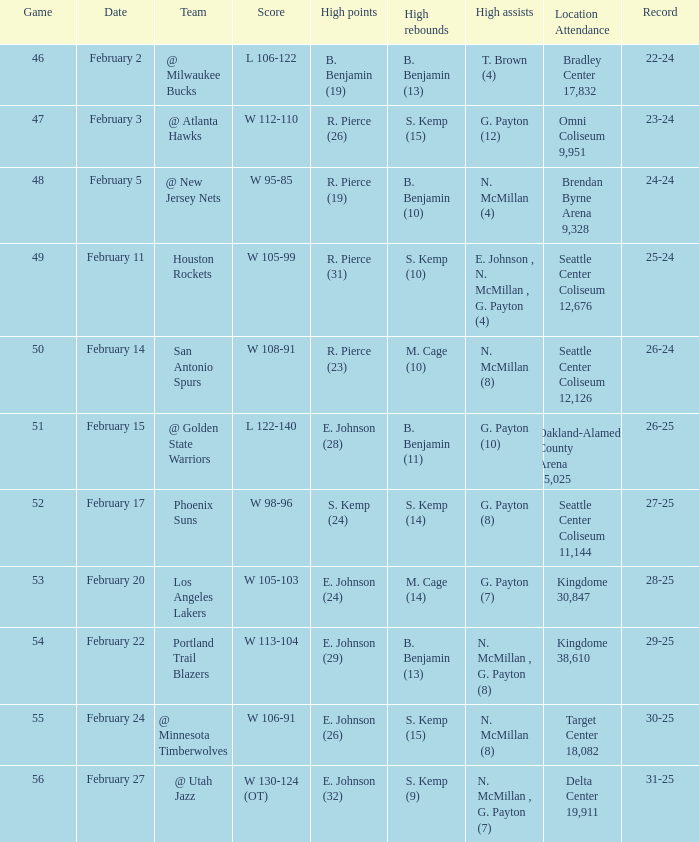What is the location and attendance for the game where b. benjamin (10) had the high rebounds? Brendan Byrne Arena 9,328. 